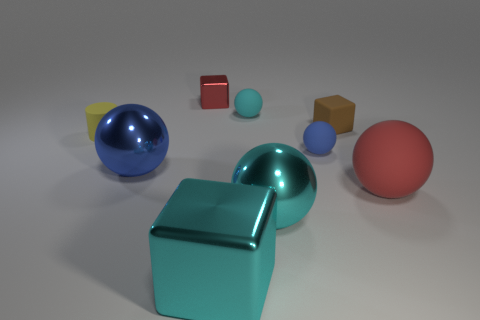Are there any objects in this image that look similar to the cyan cube? Yes, the blue sphere and the pink sphere resemble the cyan cube in terms of having a similar smooth texture and a reflection that suggests they are made of a similar material. 